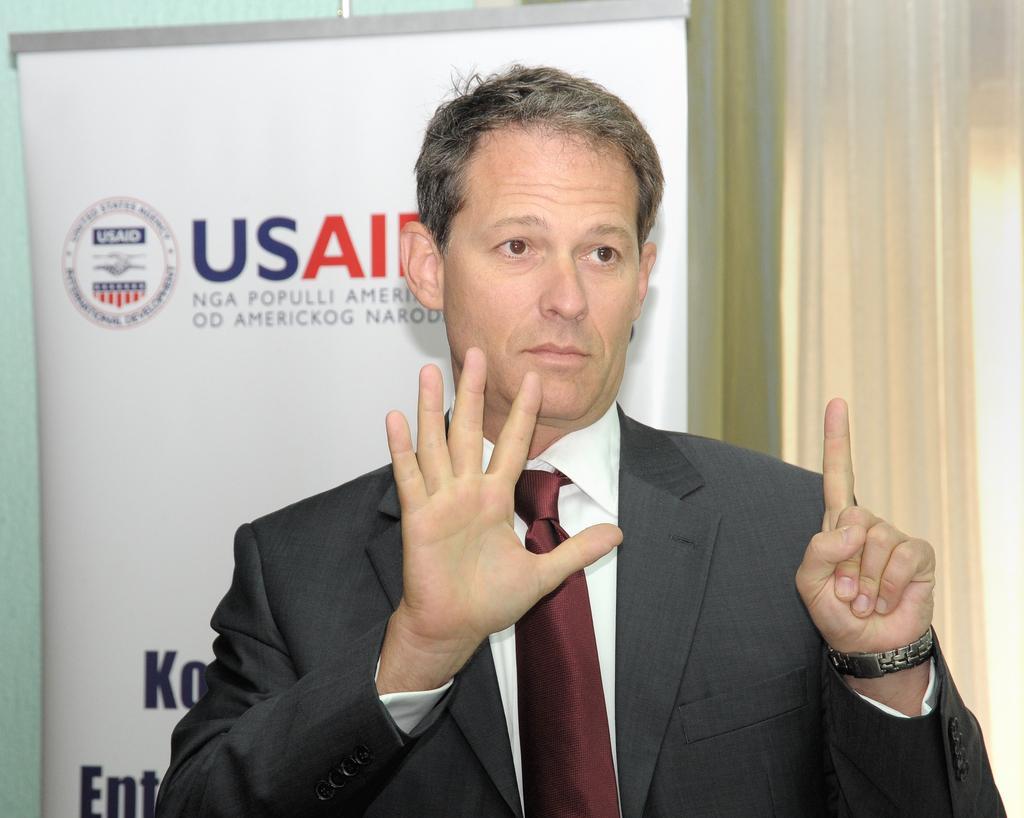Please provide a concise description of this image. In the picture there is a man,he is wearing a blazer and he is showing his six fingers and behind the man there is a banner and behind the banner there is a curtain. 